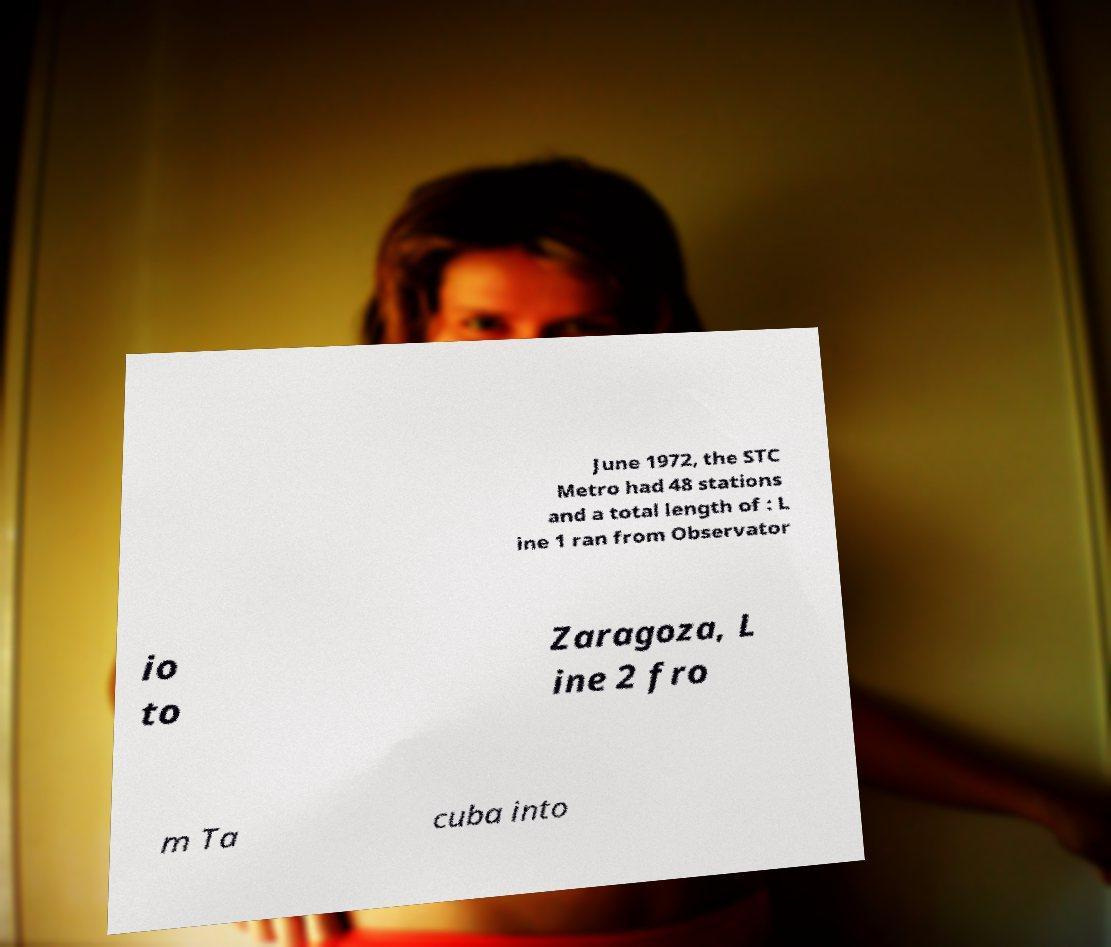Could you assist in decoding the text presented in this image and type it out clearly? June 1972, the STC Metro had 48 stations and a total length of : L ine 1 ran from Observator io to Zaragoza, L ine 2 fro m Ta cuba into 